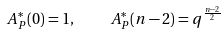<formula> <loc_0><loc_0><loc_500><loc_500>A _ { P } ^ { * } ( 0 ) = 1 , \quad A _ { P } ^ { * } ( n - 2 ) = q ^ { \frac { n - 2 } 2 }</formula> 